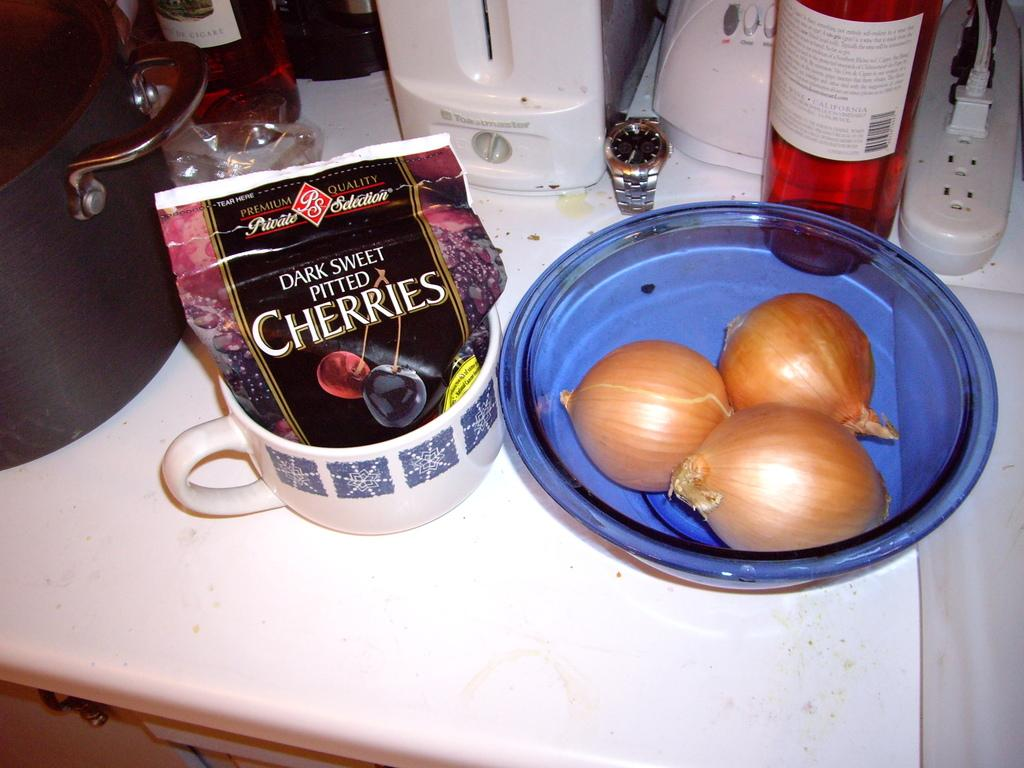What type of food items are in the bowl on the table? There are three onions in a bowl on the table. What type of beverages are on the table? There are wine bottles on the table. What type of devices are on the table? There are electronic devices on the table. What type of box is on the table? There is a connect box on the table. What type of container is in a cup on the table? There is a packet in a cup on the table. What type of accessory is on the table? There is a watch on the table. What type of vessel is on the table? There is a vessel on the table. How does the watch pull the stove in the image? There is no stove present in the image, and the watch is not shown interacting with any other object. 